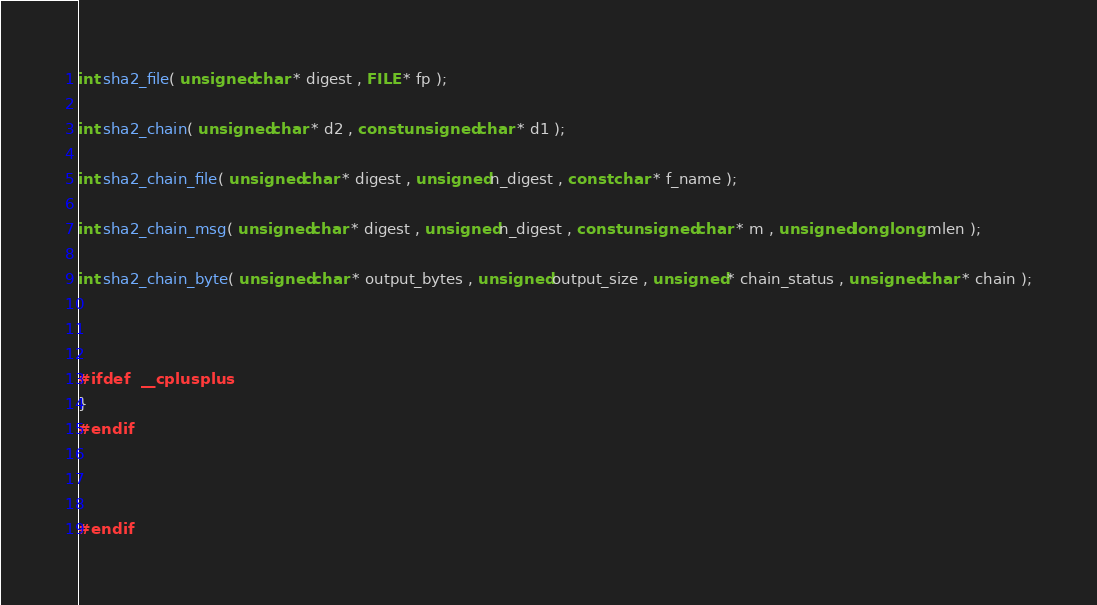Convert code to text. <code><loc_0><loc_0><loc_500><loc_500><_C_>int sha2_file( unsigned char * digest , FILE * fp );

int sha2_chain( unsigned char * d2 , const unsigned char * d1 );

int sha2_chain_file( unsigned char * digest , unsigned n_digest , const char * f_name );

int sha2_chain_msg( unsigned char * digest , unsigned n_digest , const unsigned char * m , unsigned long long mlen );

int sha2_chain_byte( unsigned char * output_bytes , unsigned output_size , unsigned * chain_status , unsigned char * chain );



#ifdef  __cplusplus
}
#endif



#endif

</code> 